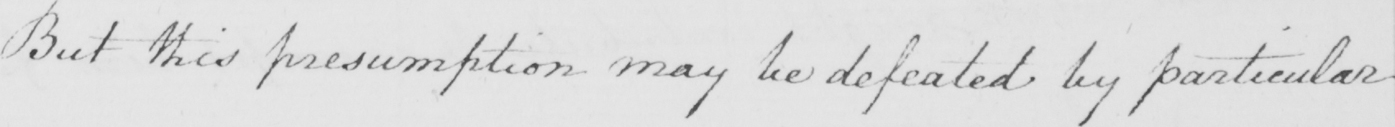Please transcribe the handwritten text in this image. But this presumption may be defeated by particular 